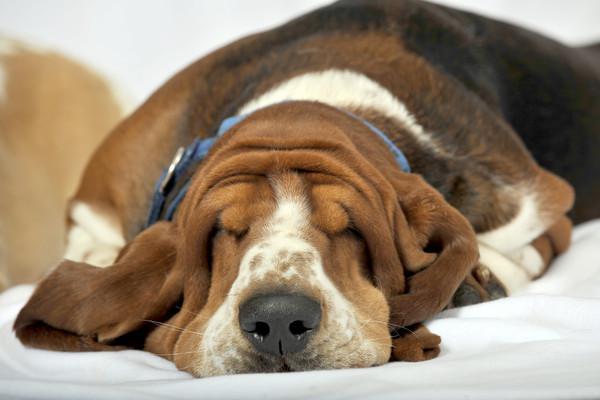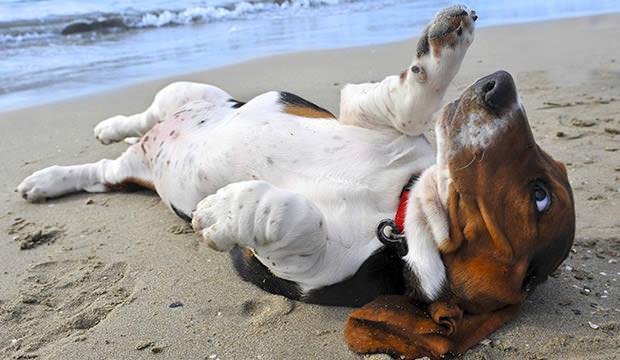The first image is the image on the left, the second image is the image on the right. Given the left and right images, does the statement "In one of the images there is a Basset Hound sleeping on its tummy." hold true? Answer yes or no. Yes. The first image is the image on the left, the second image is the image on the right. For the images displayed, is the sentence "Each image contains one basset hound, and one hound lies on his back while the other hound lies on his stomach with his head flat." factually correct? Answer yes or no. Yes. 